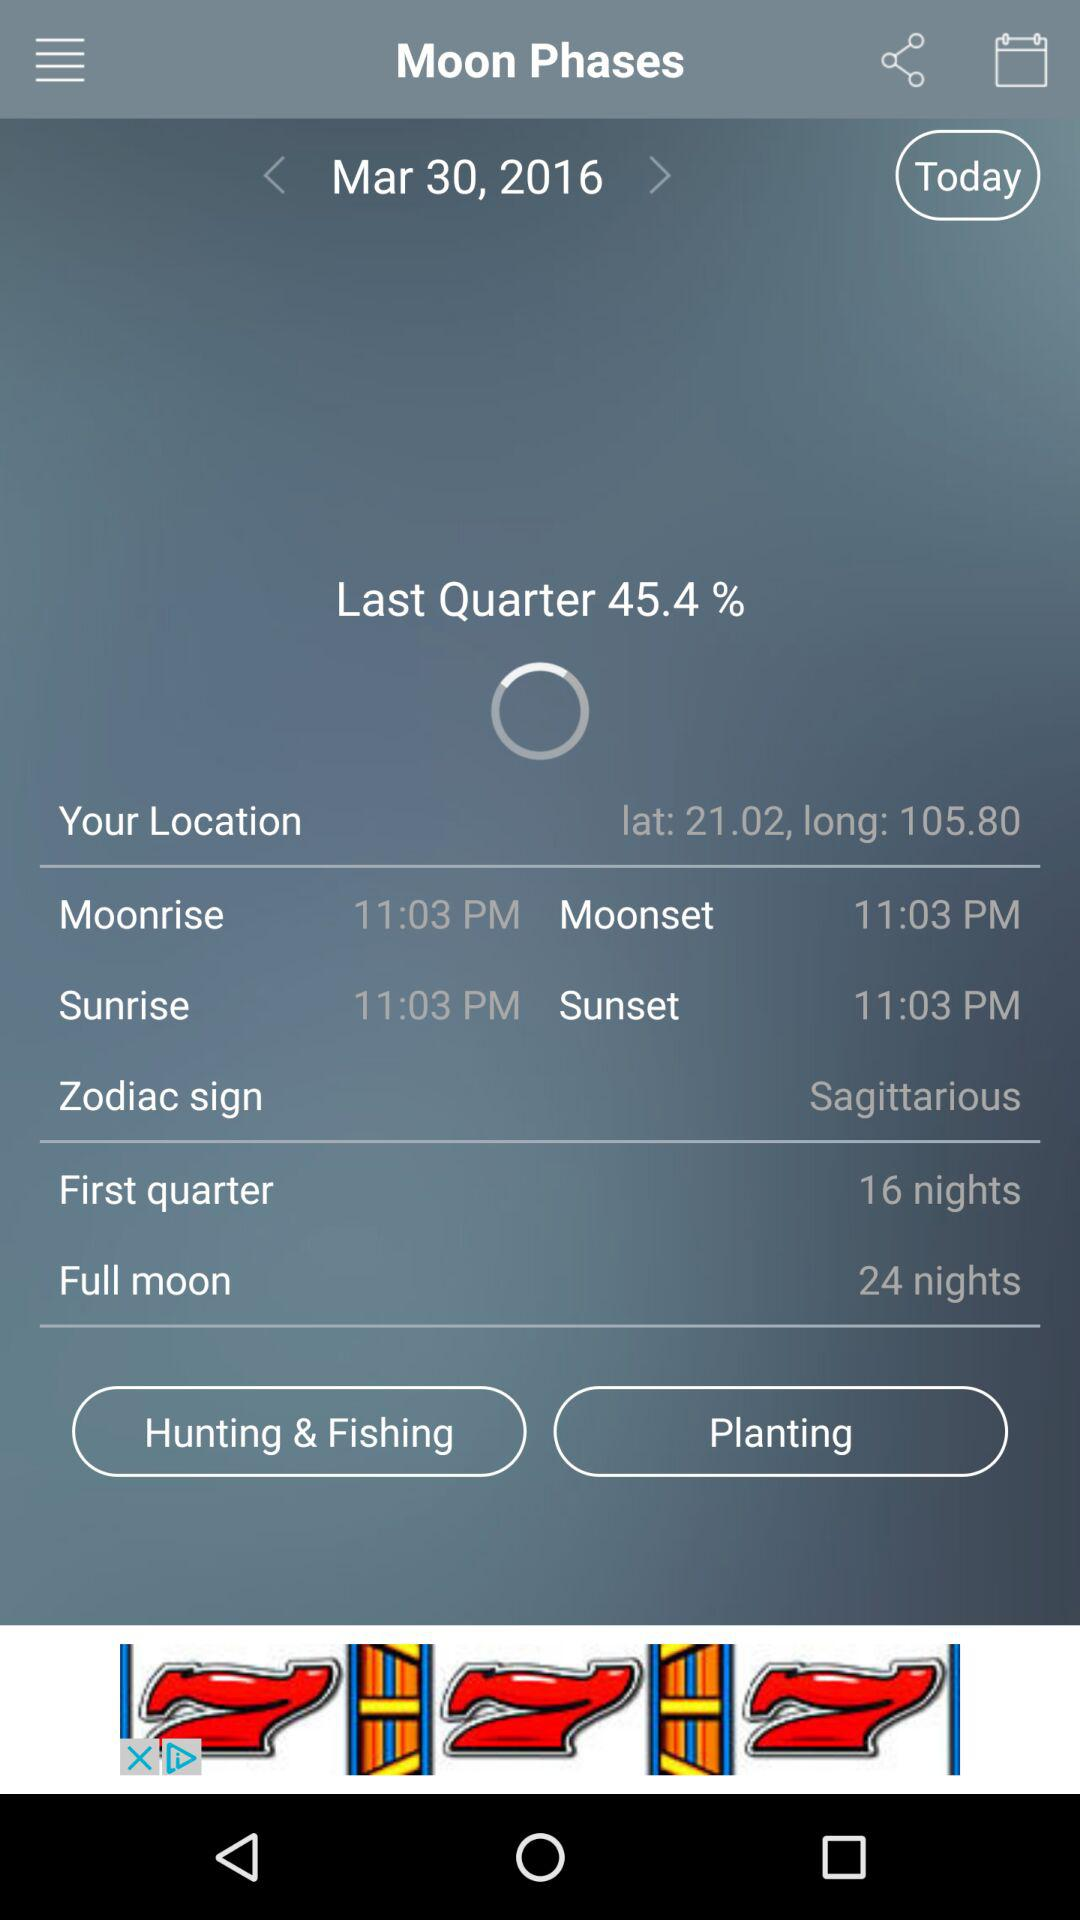What is the time of the sunset? The time of the sunset is 11:03 PM. 